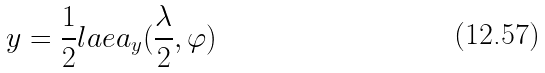Convert formula to latex. <formula><loc_0><loc_0><loc_500><loc_500>y = \frac { 1 } { 2 } l a e a _ { y } ( \frac { \lambda } { 2 } , \varphi )</formula> 